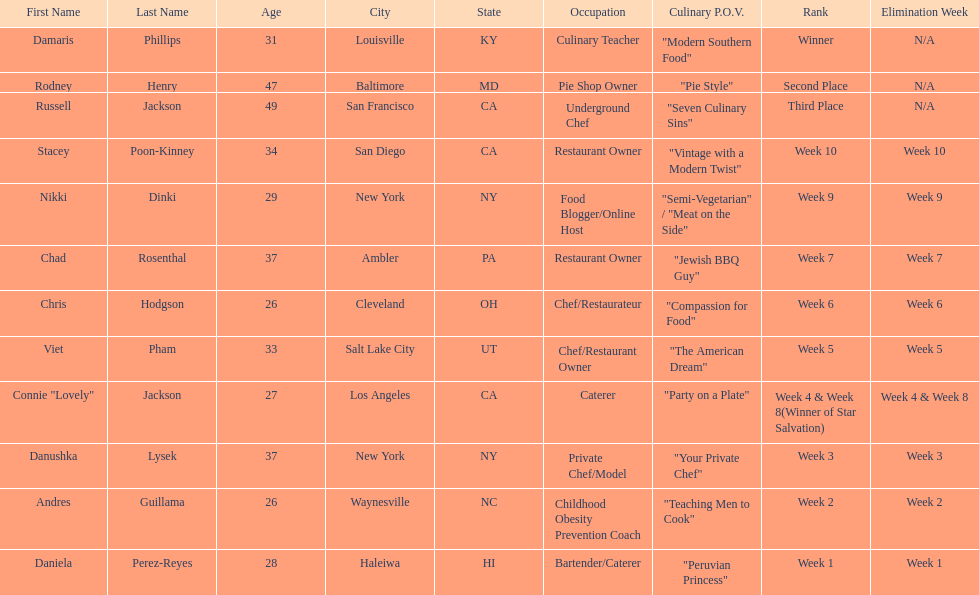How many competitors were under the age of 30? 5. 